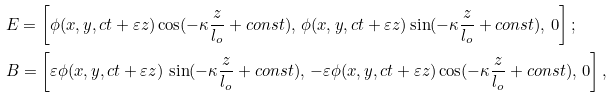<formula> <loc_0><loc_0><loc_500><loc_500>& E = \left [ \phi ( x , y , c t + \varepsilon z ) \cos ( - \kappa \frac { z } { l _ { o } } + c o n s t ) , \, \phi ( x , y , c t + \varepsilon z ) \sin ( - \kappa \frac { z } { l _ { o } } + c o n s t ) , \, 0 \right ] ; \\ & B = \left [ \varepsilon \phi ( x , y , c t + \varepsilon z ) \, \sin ( - \kappa \frac { z } { l _ { o } } + c o n s t ) , \, - \varepsilon \phi ( x , y , c t + \varepsilon z ) \cos ( - \kappa \frac { z } { l _ { o } } + c o n s t ) , \, 0 \right ] ,</formula> 